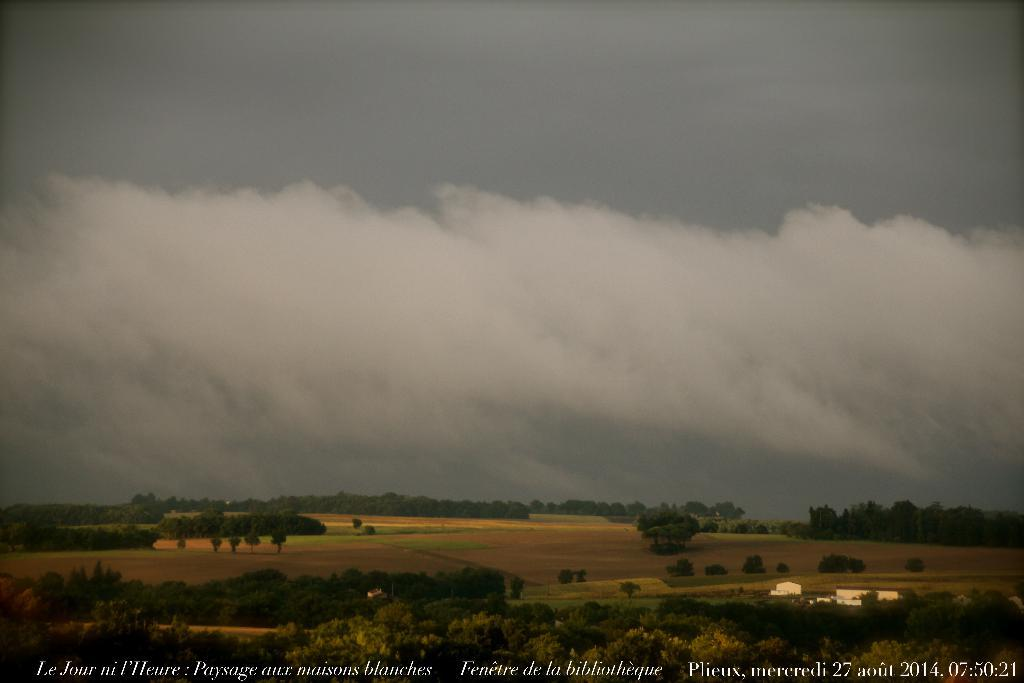What type of natural vegetation can be seen in the image? There are trees in the image. What type of landscape is visible in the image? There are fields in the image. What is visible in the background of the image? The sky is visible in the background of the image. What is written or displayed at the bottom of the image? There is text at the bottom of the image. What type of structures can be seen in the image? There are sheds in the image. Can you see a knot tied in one of the trees in the image? There is no knot tied in any of the trees in the image. Is there a crook leaning against one of the sheds in the image? There is no crook present in the image. 